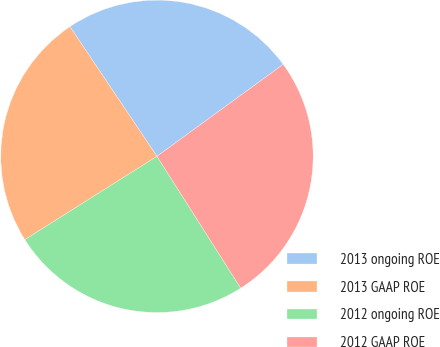Convert chart to OTSL. <chart><loc_0><loc_0><loc_500><loc_500><pie_chart><fcel>2013 ongoing ROE<fcel>2013 GAAP ROE<fcel>2012 ongoing ROE<fcel>2012 GAAP ROE<nl><fcel>24.39%<fcel>24.55%<fcel>25.05%<fcel>26.01%<nl></chart> 